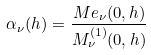Convert formula to latex. <formula><loc_0><loc_0><loc_500><loc_500>\alpha _ { \nu } ( h ) = \frac { M e _ { \nu } ( 0 , h ) } { M ^ { ( 1 ) } _ { \nu } ( 0 , h ) }</formula> 